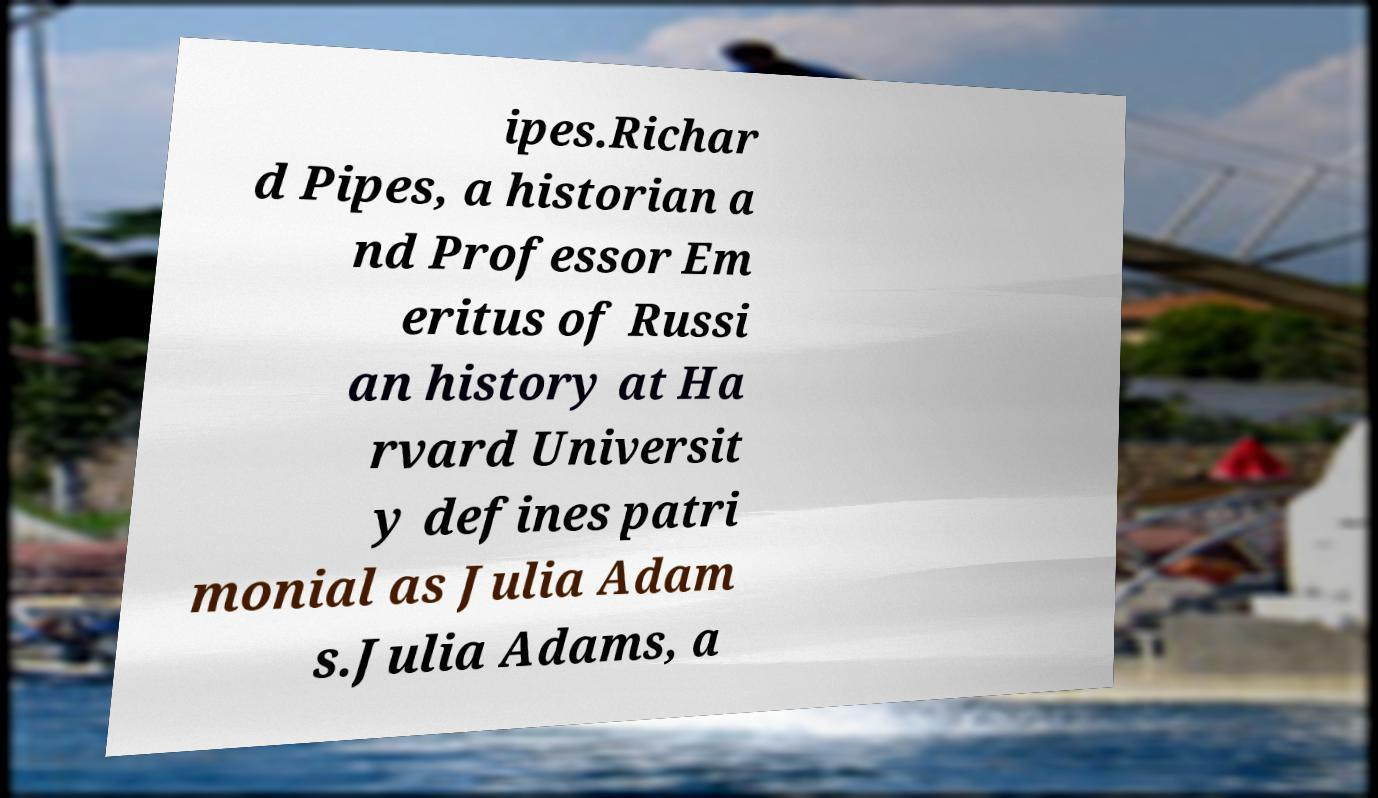I need the written content from this picture converted into text. Can you do that? ipes.Richar d Pipes, a historian a nd Professor Em eritus of Russi an history at Ha rvard Universit y defines patri monial as Julia Adam s.Julia Adams, a 